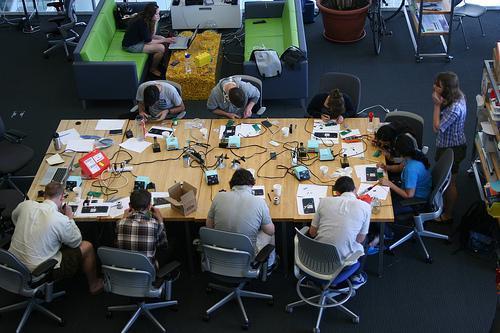How many flower pots are there?
Give a very brief answer. 1. How many people are in the room?
Give a very brief answer. 11. How many people are standing?
Give a very brief answer. 1. 